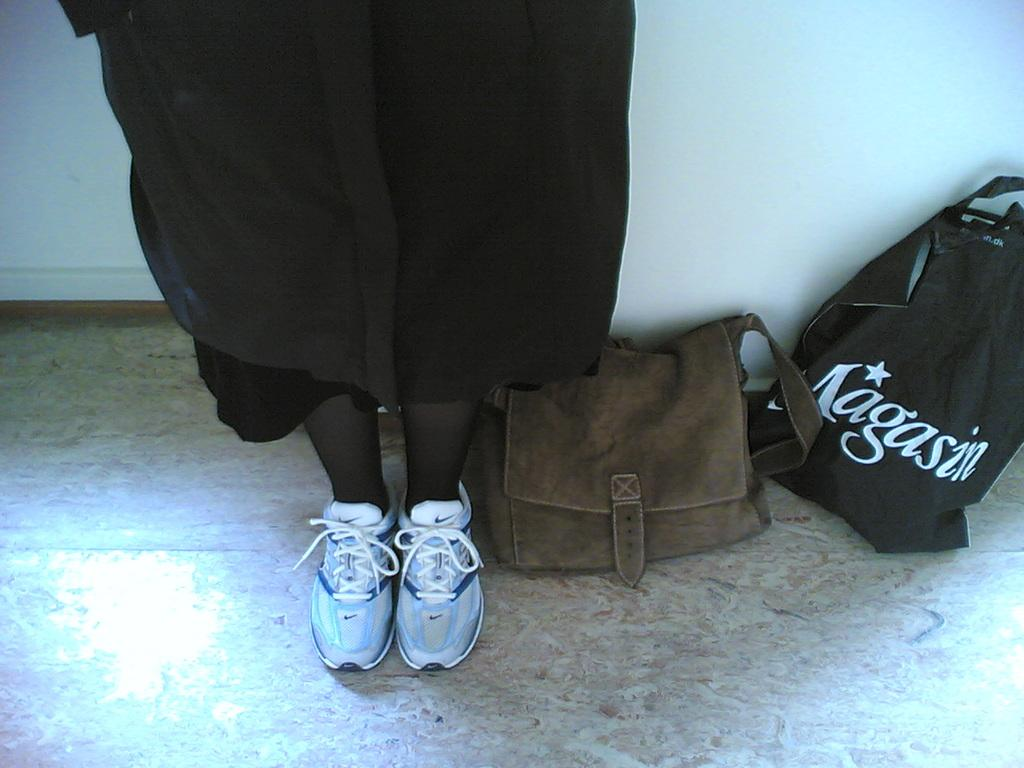How many bags can be seen in the image? There are two bags in the image. What is the person wearing in the image? The person is wearing a black dress and white shoes. What color is the wall at the top of the image? The wall at the top of the image is painted white. What type of flooring is visible at the bottom of the image? There are tiles visible at the bottom of the image. Can you see any mittens in the image? No, there are no mittens present in the image. Where is the lunchroom located in the image? There is no mention of a lunchroom in the image; it only shows two bags, a person, a wall, and tiles. 